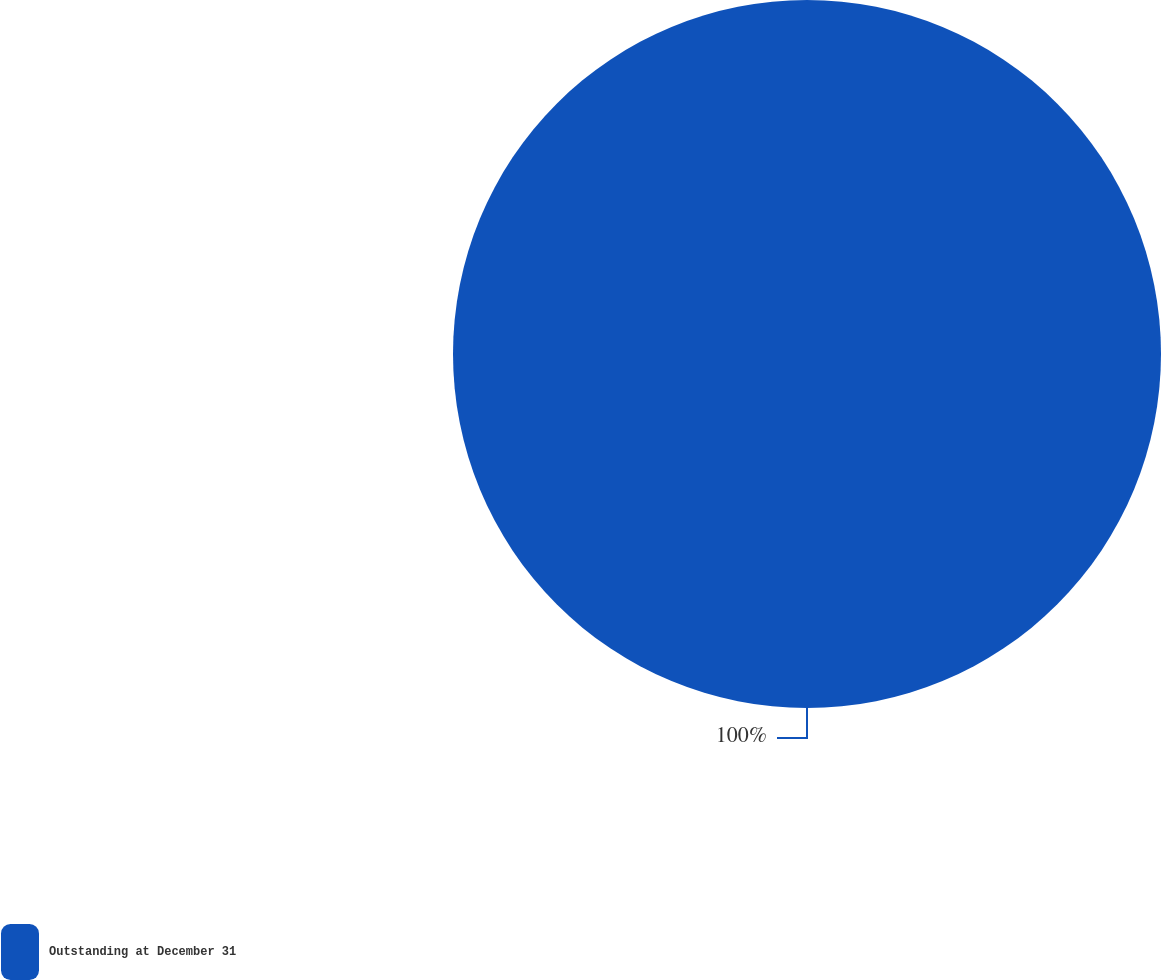Convert chart. <chart><loc_0><loc_0><loc_500><loc_500><pie_chart><fcel>Outstanding at December 31<nl><fcel>100.0%<nl></chart> 